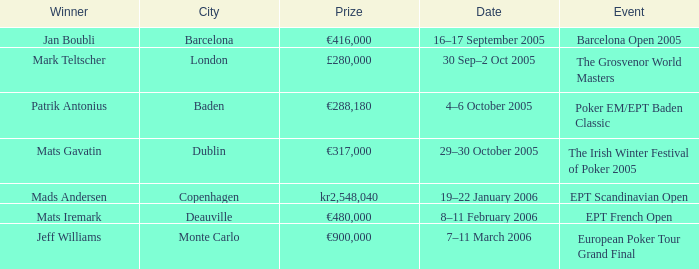What event had a prize of €900,000? European Poker Tour Grand Final. 